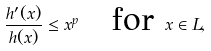<formula> <loc_0><loc_0><loc_500><loc_500>\frac { h ^ { \prime } ( x ) } { h ( x ) } \leq x ^ { p } \quad \text {for } x \in L ,</formula> 